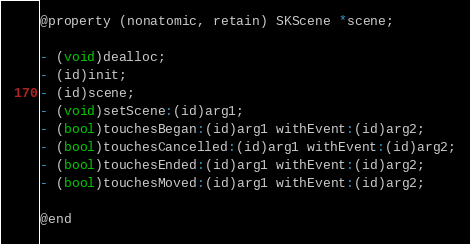Convert code to text. <code><loc_0><loc_0><loc_500><loc_500><_C_>
@property (nonatomic, retain) SKScene *scene;

- (void)dealloc;
- (id)init;
- (id)scene;
- (void)setScene:(id)arg1;
- (bool)touchesBegan:(id)arg1 withEvent:(id)arg2;
- (bool)touchesCancelled:(id)arg1 withEvent:(id)arg2;
- (bool)touchesEnded:(id)arg1 withEvent:(id)arg2;
- (bool)touchesMoved:(id)arg1 withEvent:(id)arg2;

@end
</code> 